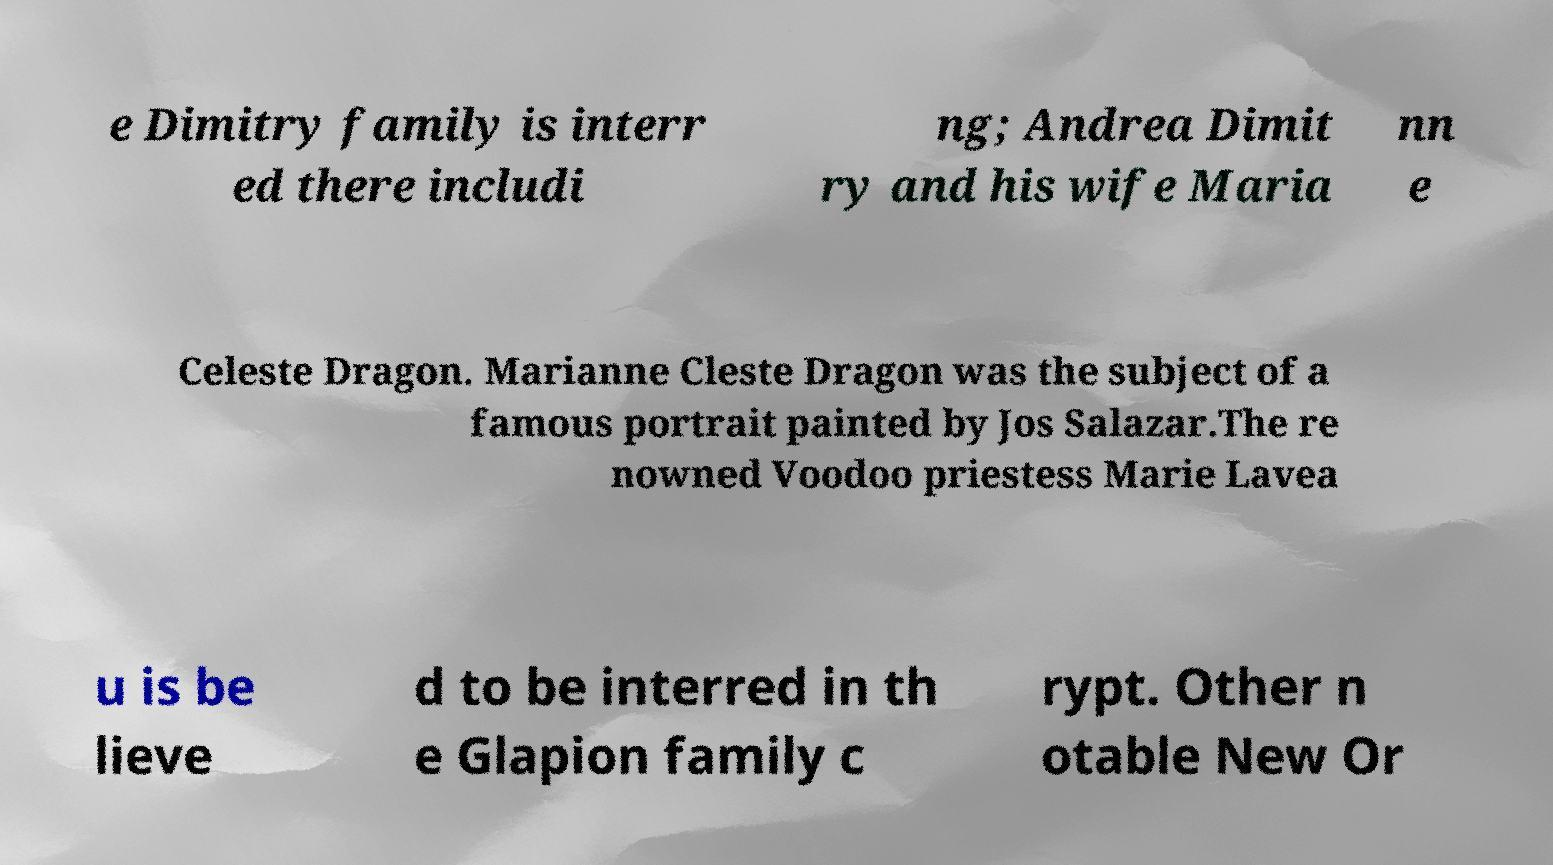Could you extract and type out the text from this image? e Dimitry family is interr ed there includi ng; Andrea Dimit ry and his wife Maria nn e Celeste Dragon. Marianne Cleste Dragon was the subject of a famous portrait painted by Jos Salazar.The re nowned Voodoo priestess Marie Lavea u is be lieve d to be interred in th e Glapion family c rypt. Other n otable New Or 